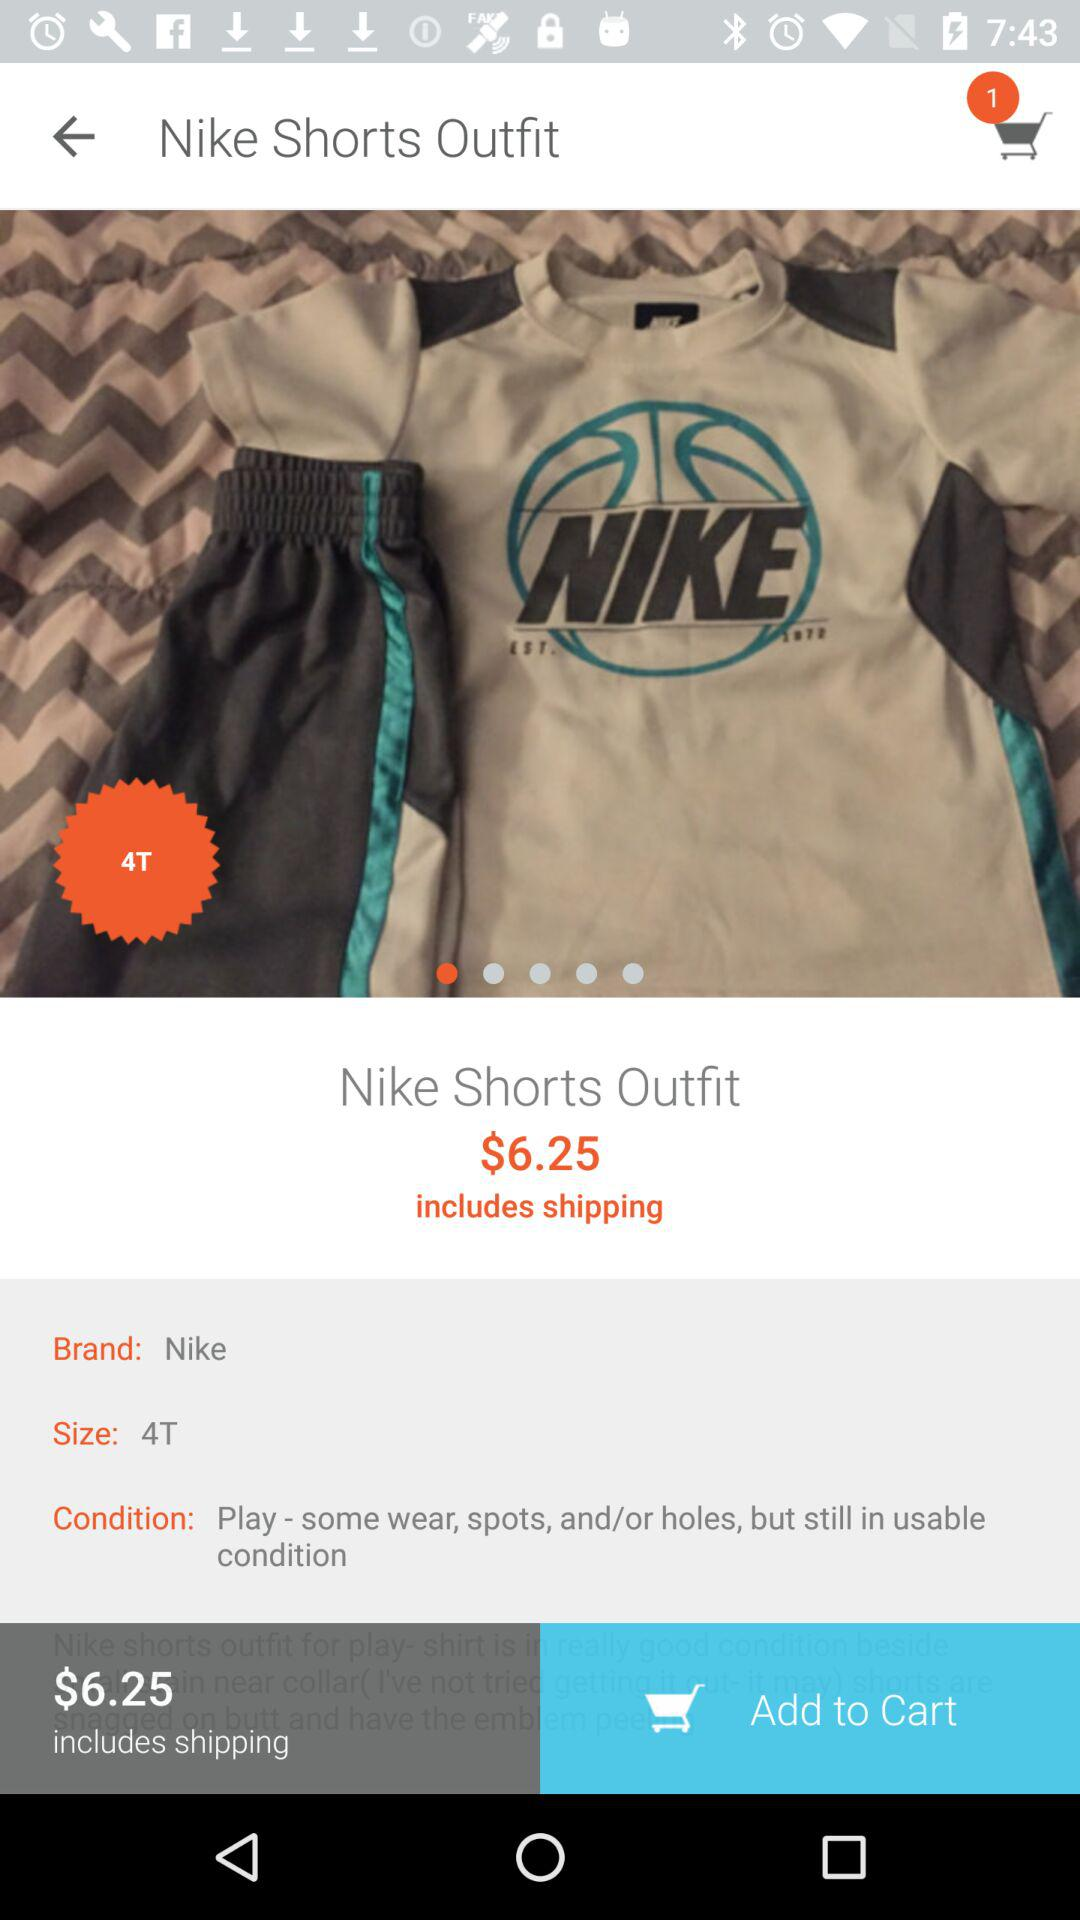What is the condition of the outfit? The condition is "Play - some wear, spots, and/or holes, but still in usable condition". 